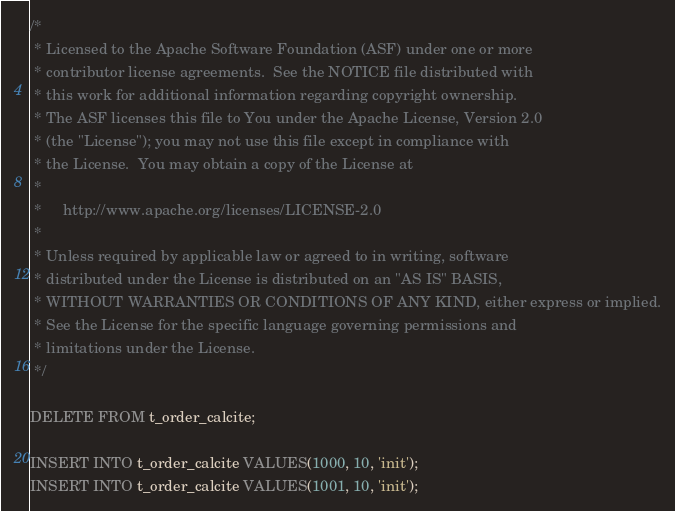Convert code to text. <code><loc_0><loc_0><loc_500><loc_500><_SQL_>/*
 * Licensed to the Apache Software Foundation (ASF) under one or more
 * contributor license agreements.  See the NOTICE file distributed with
 * this work for additional information regarding copyright ownership.
 * The ASF licenses this file to You under the Apache License, Version 2.0
 * (the "License"); you may not use this file except in compliance with
 * the License.  You may obtain a copy of the License at
 *
 *     http://www.apache.org/licenses/LICENSE-2.0
 *
 * Unless required by applicable law or agreed to in writing, software
 * distributed under the License is distributed on an "AS IS" BASIS,
 * WITHOUT WARRANTIES OR CONDITIONS OF ANY KIND, either express or implied.
 * See the License for the specific language governing permissions and
 * limitations under the License.
 */

DELETE FROM t_order_calcite;

INSERT INTO t_order_calcite VALUES(1000, 10, 'init');
INSERT INTO t_order_calcite VALUES(1001, 10, 'init');</code> 